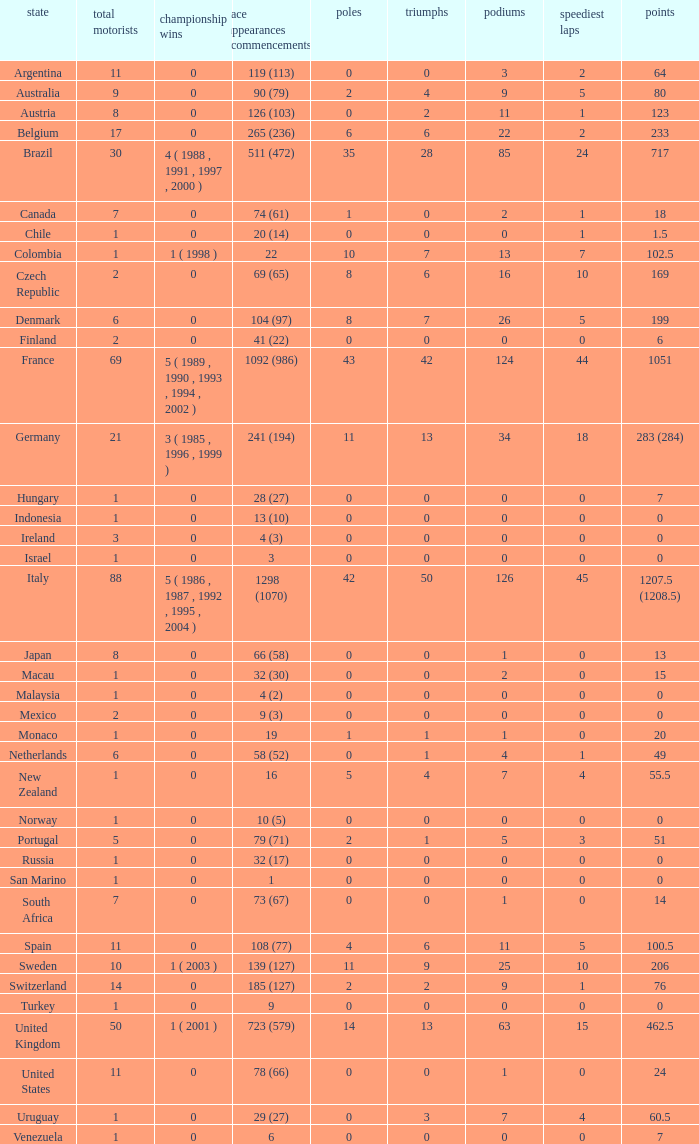How many fastest laps for the nation with 32 (30) entries and starts and fewer than 2 podiums? None. 